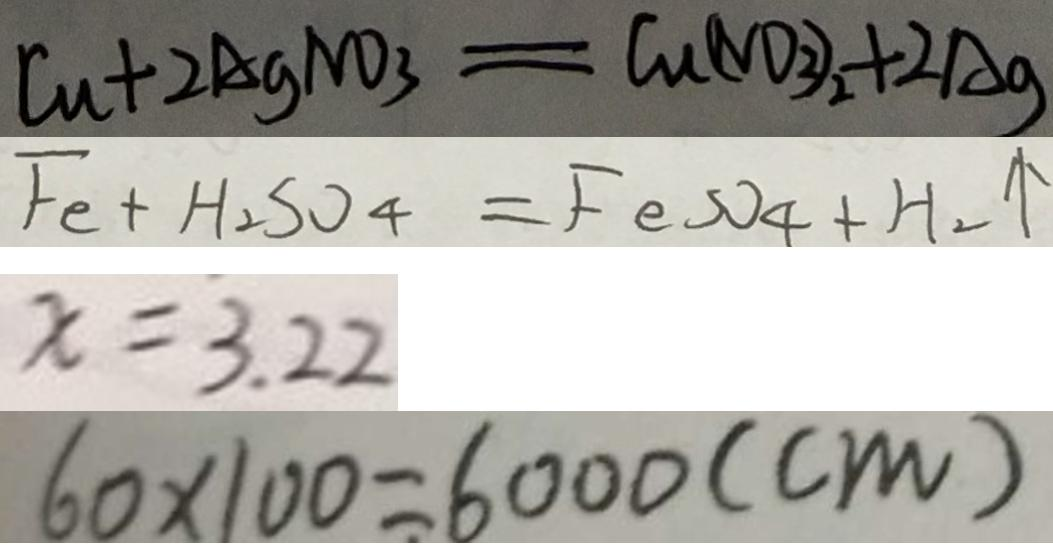<formula> <loc_0><loc_0><loc_500><loc_500>C u + 2 A g N O _ { 3 } = C u ( N O _ { 3 } ) _ { 2 } + 2 A g 
 F _ { 2 } + H _ { 2 } S O _ { 4 } = F e s O _ { 4 } + H _ { 2 } \uparrow 
 x = 3 . 2 2 
 6 0 \times 1 0 0 = 6 0 0 0 ( c m )</formula> 